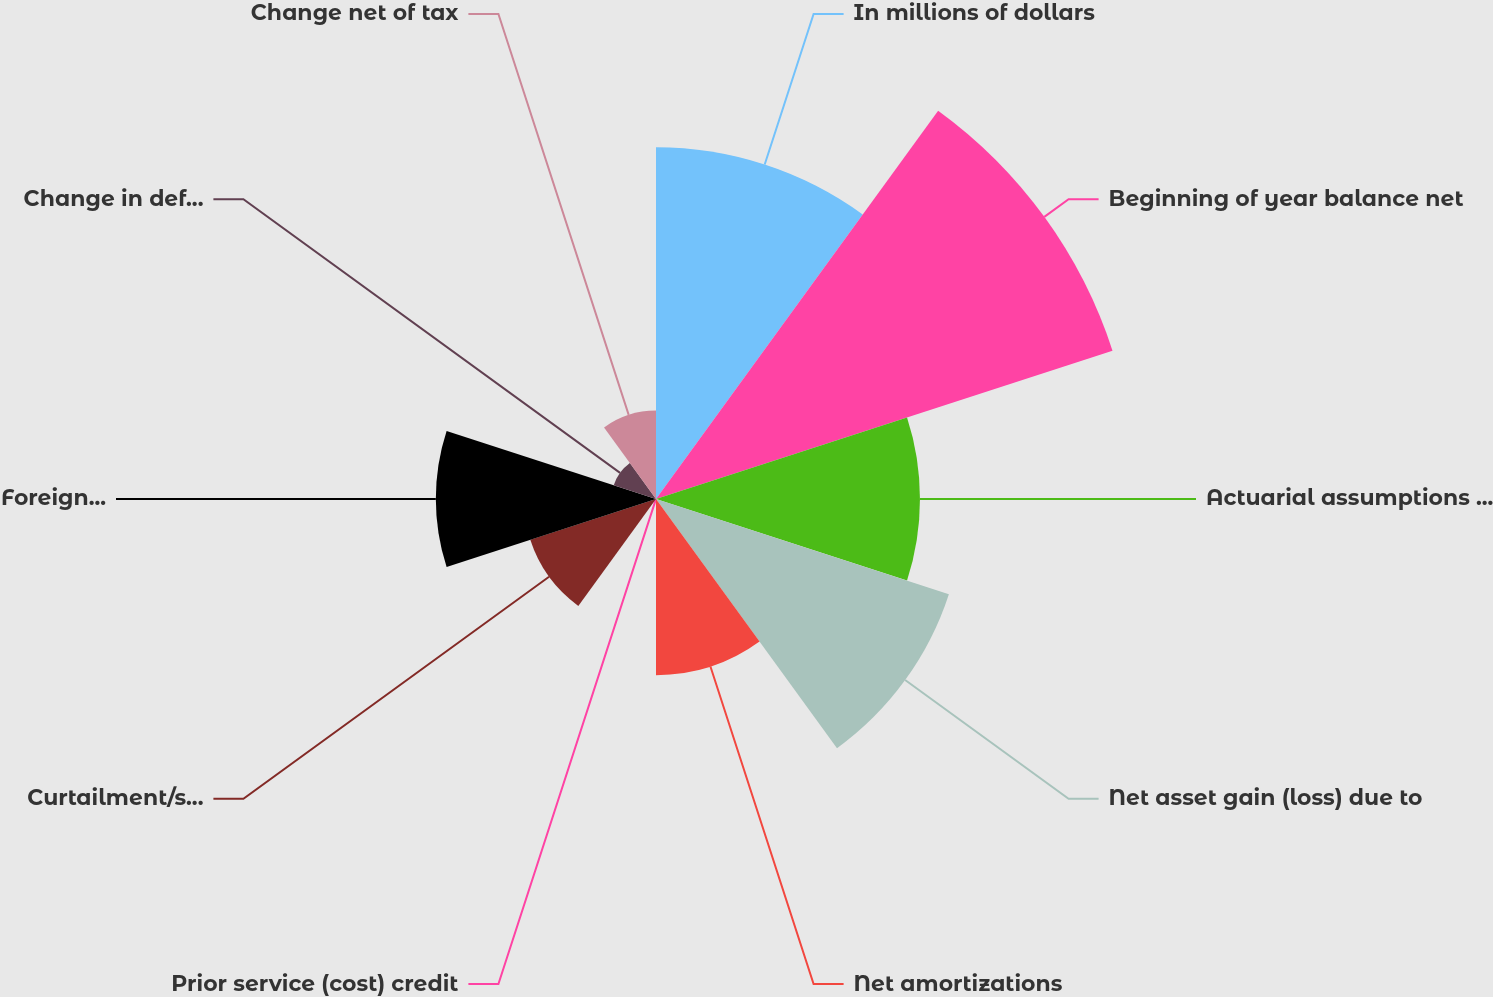<chart> <loc_0><loc_0><loc_500><loc_500><pie_chart><fcel>In millions of dollars<fcel>Beginning of year balance net<fcel>Actuarial assumptions changes<fcel>Net asset gain (loss) due to<fcel>Net amortizations<fcel>Prior service (cost) credit<fcel>Curtailment/settlement gain<fcel>Foreign exchange impact and<fcel>Change in deferred taxes net<fcel>Change net of tax<nl><fcel>17.03%<fcel>23.24%<fcel>12.78%<fcel>14.91%<fcel>8.53%<fcel>0.02%<fcel>6.4%<fcel>10.66%<fcel>2.15%<fcel>4.28%<nl></chart> 